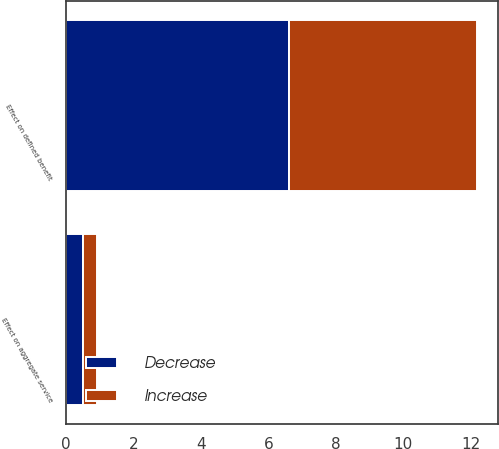Convert chart to OTSL. <chart><loc_0><loc_0><loc_500><loc_500><stacked_bar_chart><ecel><fcel>Effect on aggregate service<fcel>Effect on defined benefit<nl><fcel>Decrease<fcel>0.5<fcel>6.6<nl><fcel>Increase<fcel>0.4<fcel>5.6<nl></chart> 